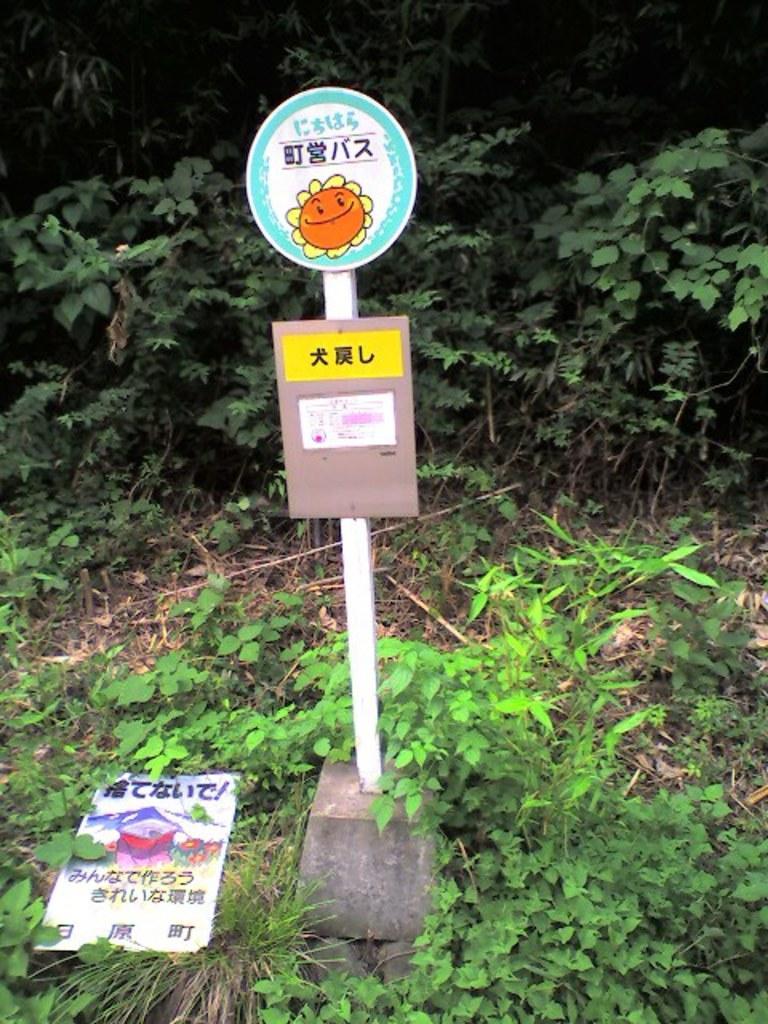How would you summarize this image in a sentence or two? In this image we can see plants, pole, boards, and grass. 